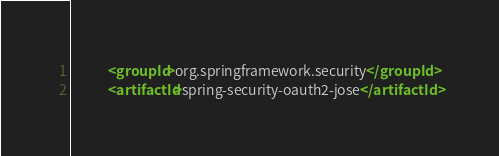<code> <loc_0><loc_0><loc_500><loc_500><_XML_>            <groupId>org.springframework.security</groupId>
            <artifactId>spring-security-oauth2-jose</artifactId></code> 